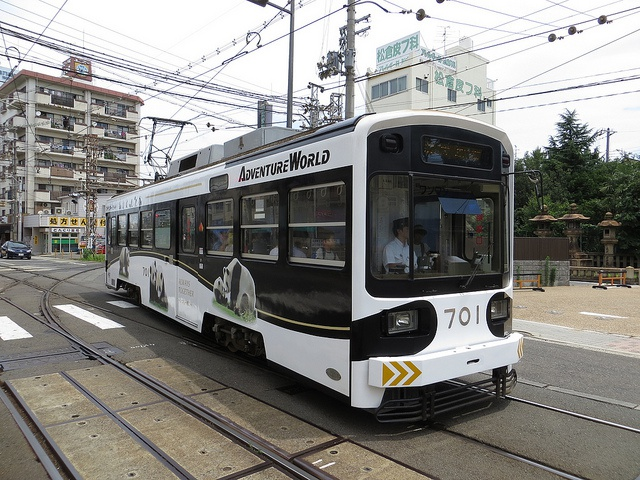Describe the objects in this image and their specific colors. I can see train in lavender, black, darkgray, lightgray, and gray tones, people in lavender, black, and gray tones, people in lavender, black, and gray tones, car in lavender, black, gray, and darkgray tones, and people in lavender, black, and gray tones in this image. 